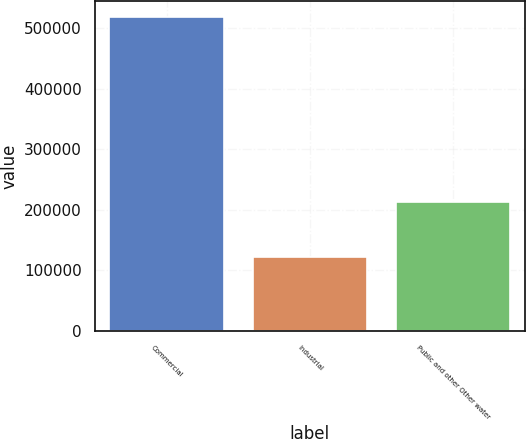Convert chart to OTSL. <chart><loc_0><loc_0><loc_500><loc_500><bar_chart><fcel>Commercial<fcel>Industrial<fcel>Public and other Other water<nl><fcel>518253<fcel>121902<fcel>212289<nl></chart> 